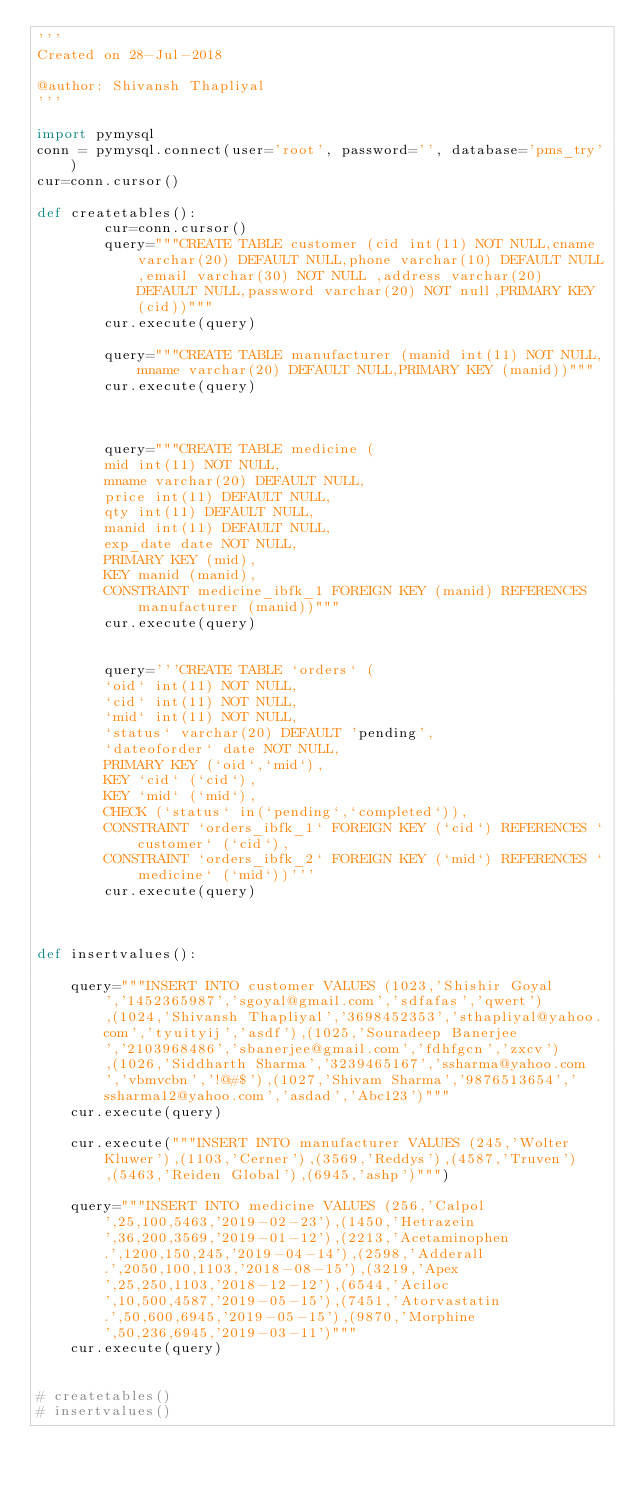Convert code to text. <code><loc_0><loc_0><loc_500><loc_500><_Python_>'''
Created on 28-Jul-2018

@author: Shivansh Thapliyal
'''

import pymysql
conn = pymysql.connect(user='root', password='', database='pms_try')
cur=conn.cursor()

def createtables():
        cur=conn.cursor()
        query="""CREATE TABLE customer (cid int(11) NOT NULL,cname varchar(20) DEFAULT NULL,phone varchar(10) DEFAULT NULL,email varchar(30) NOT NULL ,address varchar(20) DEFAULT NULL,password varchar(20) NOT null,PRIMARY KEY (cid))"""
        cur.execute(query)

        query="""CREATE TABLE manufacturer (manid int(11) NOT NULL,mname varchar(20) DEFAULT NULL,PRIMARY KEY (manid))"""
        cur.execute(query)



        query="""CREATE TABLE medicine (
        mid int(11) NOT NULL,
        mname varchar(20) DEFAULT NULL,
        price int(11) DEFAULT NULL,
        qty int(11) DEFAULT NULL,
        manid int(11) DEFAULT NULL,
        exp_date date NOT NULL,
        PRIMARY KEY (mid),
        KEY manid (manid),
        CONSTRAINT medicine_ibfk_1 FOREIGN KEY (manid) REFERENCES manufacturer (manid))"""
        cur.execute(query)


        query='''CREATE TABLE `orders` (
        `oid` int(11) NOT NULL,
        `cid` int(11) NOT NULL,
        `mid` int(11) NOT NULL,
        `status` varchar(20) DEFAULT 'pending',
        `dateoforder` date NOT NULL,
        PRIMARY KEY (`oid`,`mid`),
        KEY `cid` (`cid`),
        KEY `mid` (`mid`),
        CHECK (`status` in(`pending`,`completed`)),
        CONSTRAINT `orders_ibfk_1` FOREIGN KEY (`cid`) REFERENCES `customer` (`cid`),
        CONSTRAINT `orders_ibfk_2` FOREIGN KEY (`mid`) REFERENCES `medicine` (`mid`))'''
        cur.execute(query)



def insertvalues():

    query="""INSERT INTO customer VALUES (1023,'Shishir Goyal','1452365987','sgoyal@gmail.com','sdfafas','qwert'),(1024,'Shivansh Thapliyal','3698452353','sthapliyal@yahoo.com','tyuityij','asdf'),(1025,'Souradeep Banerjee','2103968486','sbanerjee@gmail.com','fdhfgcn','zxcv'),(1026,'Siddharth Sharma','3239465167','ssharma@yahoo.com','vbmvcbn','!@#$'),(1027,'Shivam Sharma','9876513654','ssharma12@yahoo.com','asdad','Abc123')"""
    cur.execute(query)

    cur.execute("""INSERT INTO manufacturer VALUES (245,'Wolter Kluwer'),(1103,'Cerner'),(3569,'Reddys'),(4587,'Truven'),(5463,'Reiden Global'),(6945,'ashp')""")

    query="""INSERT INTO medicine VALUES (256,'Calpol',25,100,5463,'2019-02-23'),(1450,'Hetrazein',36,200,3569,'2019-01-12'),(2213,'Acetaminophen.',1200,150,245,'2019-04-14'),(2598,'Adderall.',2050,100,1103,'2018-08-15'),(3219,'Apex',25,250,1103,'2018-12-12'),(6544,'Aciloc',10,500,4587,'2019-05-15'),(7451,'Atorvastatin.',50,600,6945,'2019-05-15'),(9870,'Morphine',50,236,6945,'2019-03-11')"""
    cur.execute(query)


# createtables()
# insertvalues()
</code> 